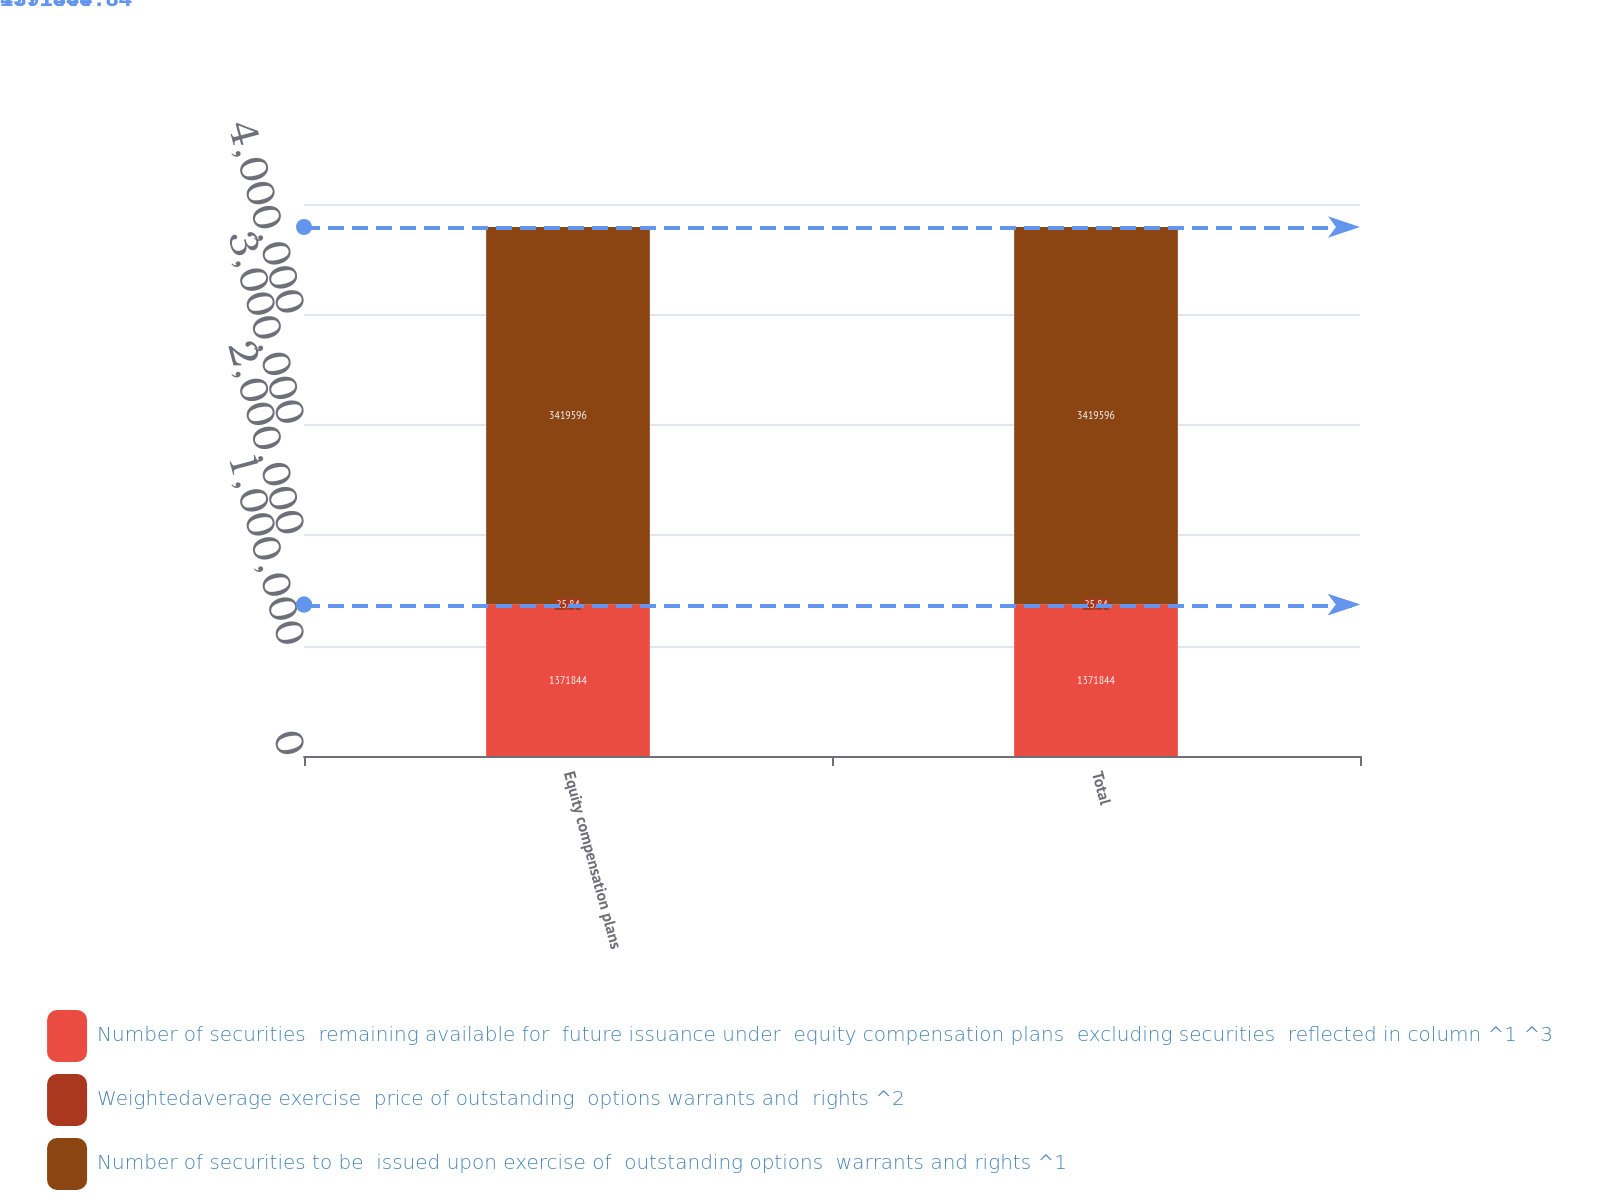<chart> <loc_0><loc_0><loc_500><loc_500><stacked_bar_chart><ecel><fcel>Equity compensation plans<fcel>Total<nl><fcel>Number of securities  remaining available for  future issuance under  equity compensation plans  excluding securities  reflected in column ^1 ^3<fcel>1.37184e+06<fcel>1.37184e+06<nl><fcel>Weightedaverage exercise  price of outstanding  options warrants and  rights ^2<fcel>25.84<fcel>25.84<nl><fcel>Number of securities to be  issued upon exercise of  outstanding options  warrants and rights ^1<fcel>3.4196e+06<fcel>3.4196e+06<nl></chart> 